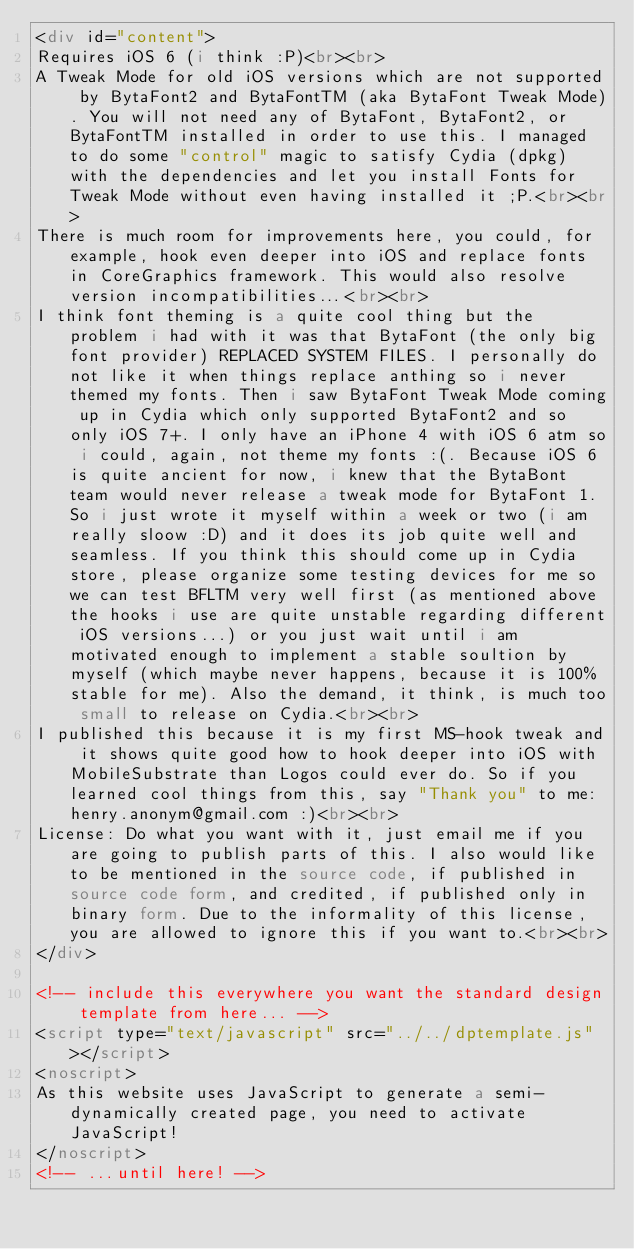<code> <loc_0><loc_0><loc_500><loc_500><_HTML_><div id="content">
Requires iOS 6 (i think :P)<br><br>
A Tweak Mode for old iOS versions which are not supported by BytaFont2 and BytaFontTM (aka BytaFont Tweak Mode). You will not need any of BytaFont, BytaFont2, or BytaFontTM installed in order to use this. I managed to do some "control" magic to satisfy Cydia (dpkg) with the dependencies and let you install Fonts for Tweak Mode without even having installed it ;P.<br><br>
There is much room for improvements here, you could, for example, hook even deeper into iOS and replace fonts in CoreGraphics framework. This would also resolve version incompatibilities...<br><br>
I think font theming is a quite cool thing but the problem i had with it was that BytaFont (the only big font provider) REPLACED SYSTEM FILES. I personally do not like it when things replace anthing so i never themed my fonts. Then i saw BytaFont Tweak Mode coming up in Cydia which only supported BytaFont2 and so only iOS 7+. I only have an iPhone 4 with iOS 6 atm so i could, again, not theme my fonts :(. Because iOS 6 is quite ancient for now, i knew that the BytaBont team would never release a tweak mode for BytaFont 1. So i just wrote it myself within a week or two (i am really sloow :D) and it does its job quite well and seamless. If you think this should come up in Cydia store, please organize some testing devices for me so we can test BFLTM very well first (as mentioned above the hooks i use are quite unstable regarding different iOS versions...) or you just wait until i am motivated enough to implement a stable soultion by myself (which maybe never happens, because it is 100% stable for me). Also the demand, it think, is much too small to release on Cydia.<br><br>
I published this because it is my first MS-hook tweak and it shows quite good how to hook deeper into iOS with MobileSubstrate than Logos could ever do. So if you learned cool things from this, say "Thank you" to me: henry.anonym@gmail.com :)<br><br>
License: Do what you want with it, just email me if you are going to publish parts of this. I also would like to be mentioned in the source code, if published in source code form, and credited, if published only in binary form. Due to the informality of this license, you are allowed to ignore this if you want to.<br><br>
</div>

<!-- include this everywhere you want the standard design template from here... -->
<script type="text/javascript" src="../../dptemplate.js"></script>
<noscript>
As this website uses JavaScript to generate a semi-dynamically created page, you need to activate JavaScript!
</noscript>
<!-- ...until here! --></code> 